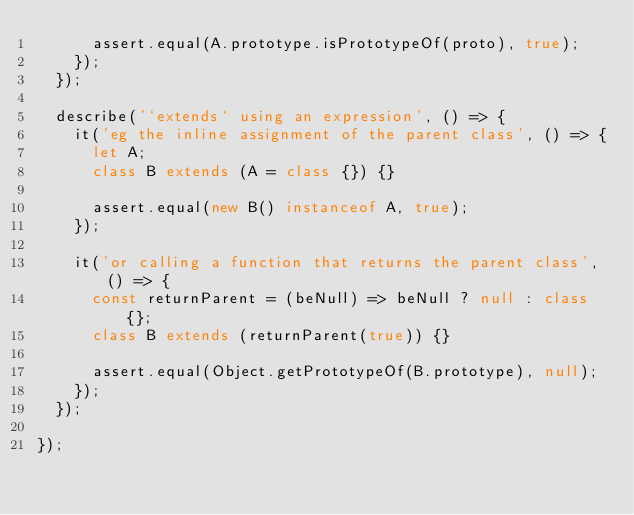Convert code to text. <code><loc_0><loc_0><loc_500><loc_500><_JavaScript_>      assert.equal(A.prototype.isPrototypeOf(proto), true);
    });
  });

  describe('`extends` using an expression', () => {
    it('eg the inline assignment of the parent class', () => {
      let A;
      class B extends (A = class {}) {}
      
      assert.equal(new B() instanceof A, true);
    });
    
    it('or calling a function that returns the parent class', () => {
      const returnParent = (beNull) => beNull ? null : class {};
      class B extends (returnParent(true)) {}
      
      assert.equal(Object.getPrototypeOf(B.prototype), null);
    });
  });
  
});
</code> 